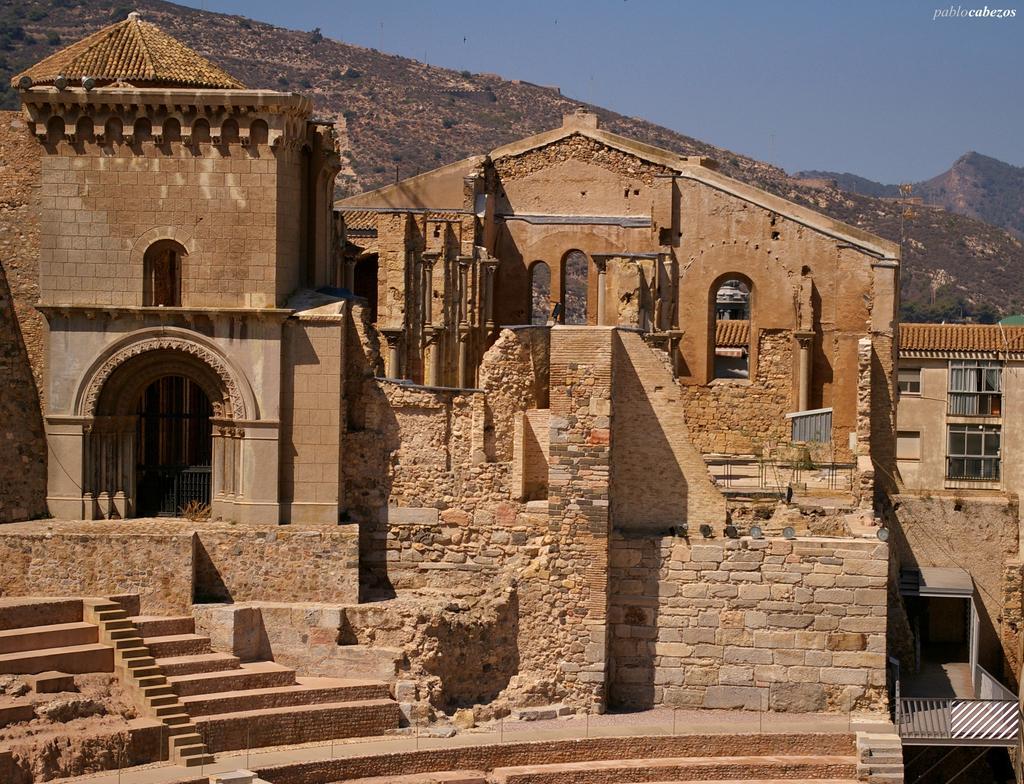Describe this image in one or two sentences. In this image I can see the buildings. In the background, I can see the hill and the sky. 